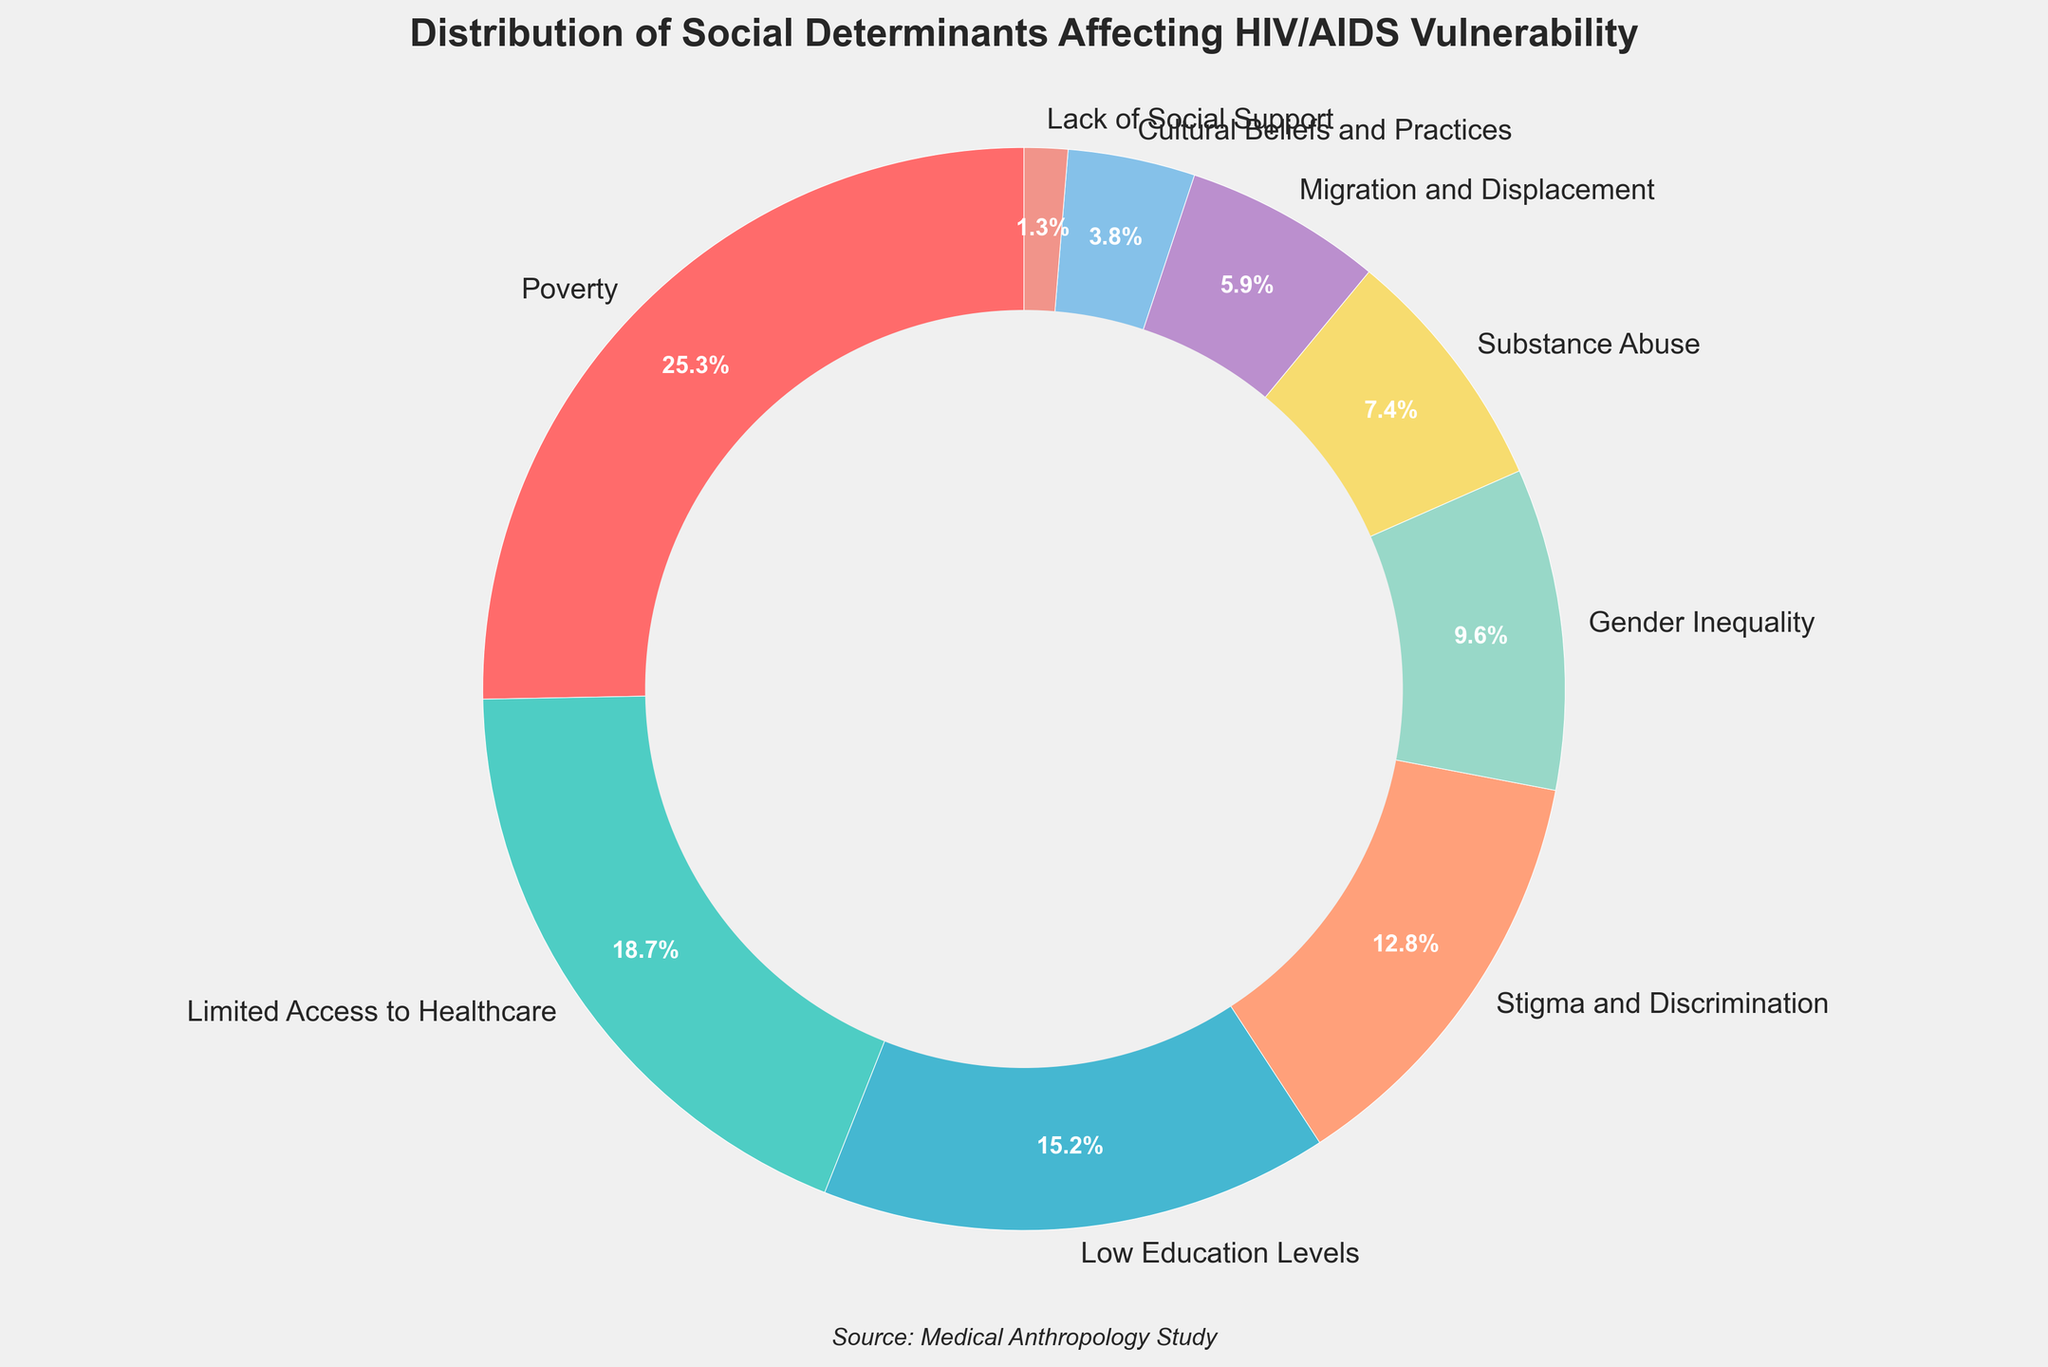Which social determinant has the highest percentage? Visually identify the largest wedge in the pie chart, which corresponds to the social determinant of poverty
Answer: Poverty What is the sum of percentages for Substance Abuse and Lack of Social Support? Substance Abuse is 7.4% and Lack of Social Support is 1.3%. Sum them: 7.4 + 1.3 = 8.7%
Answer: 8.7% Which is greater, the percentage for Low Education Levels or Gender Inequality? Compare the wedges for Low Education Levels (15.2%) and Gender Inequality (9.6%). 15.2% is greater
Answer: Low Education Levels What is the percentage difference between Limited Access to Healthcare and Migration and Displacement? Limited Access to Healthcare is 18.7% and Migration and Displacement is 5.9%. Subtract 5.9 from 18.7: 18.7 - 5.9 = 12.8%
Answer: 12.8% Which social determinant has a percentage closest to 10%? Identify the wedges closest to 10%. Gender Inequality has 9.6%, which is closest to 10%
Answer: Gender Inequality What is the combined percentage of Stigma and Discrimination, and Cultural Beliefs and Practices? Stigma and Discrimination is 12.8% and Cultural Beliefs and Practices is 3.8%. Sum them: 12.8 + 3.8 = 16.6%
Answer: 16.6% Is the percentage for Poverty greater than the sum of Migration and Displacement and Gender Inequality? Poverty is 25.3%. Migration and Displacement (5.9%) + Gender Inequality (9.6%) = 15.5%. 25.3 > 15.5
Answer: Yes How many social determinants have percentages less than 10%? Identify wedges with percentages less than 10%. These are Gender Inequality (9.6%), Substance Abuse (7.4%), Migration and Displacement (5.9%), Cultural Beliefs and Practices (3.8%), Lack of Social Support (1.3%)—total of 5 factors
Answer: 5 Which social determinant has the smallest percentage? Visually identify the smallest wedge in the pie chart. Lack of Social Support has the smallest percentage of 1.3%
Answer: Lack of Social Support What is the visual difference between the wedges for Poverty and Cultural Beliefs and Practices? Poverty occupies a much larger wedge, while Cultural Beliefs and Practices has a very small wedge visually, indicating a significant difference
Answer: Significant difference 